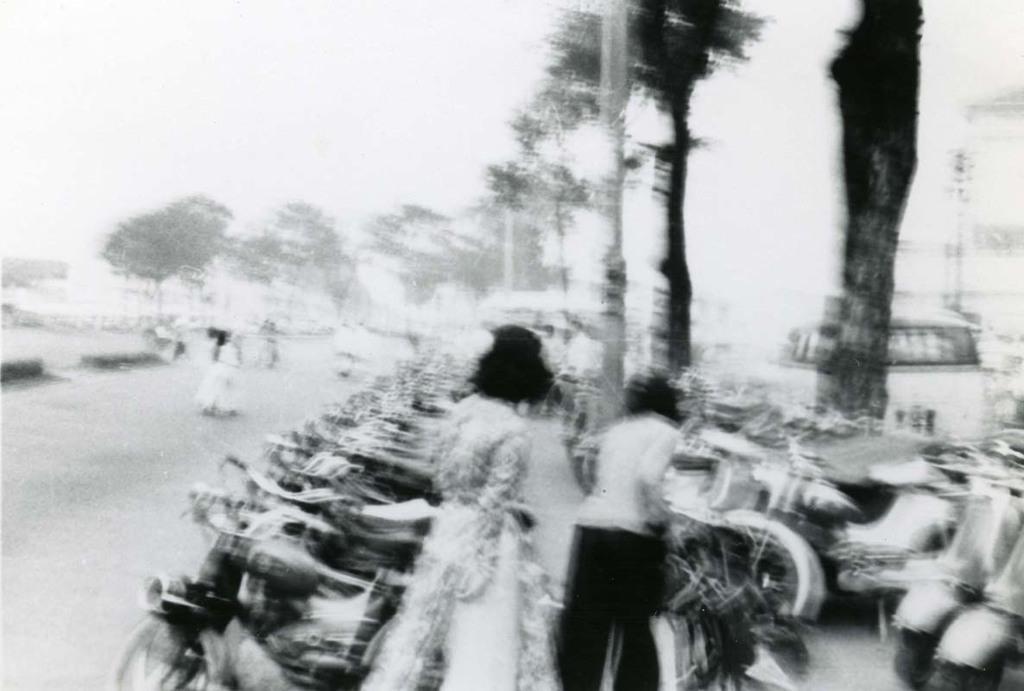What is the color scheme of the image? The image is black and white. What can be seen in the foreground of the image? There are people standing beside vehicles in the image. What is visible in the background of the image? There are trees visible in the background of the image. How would you describe the quality of the image? The image is blurry. What type of cream is being used by the people in the image? There is no cream visible or mentioned in the image. Can you identify any guns in the image? There are no guns present in the image. What musical instrument is being played by the people in the image? There is no musical instrument visible or mentioned in the image. 